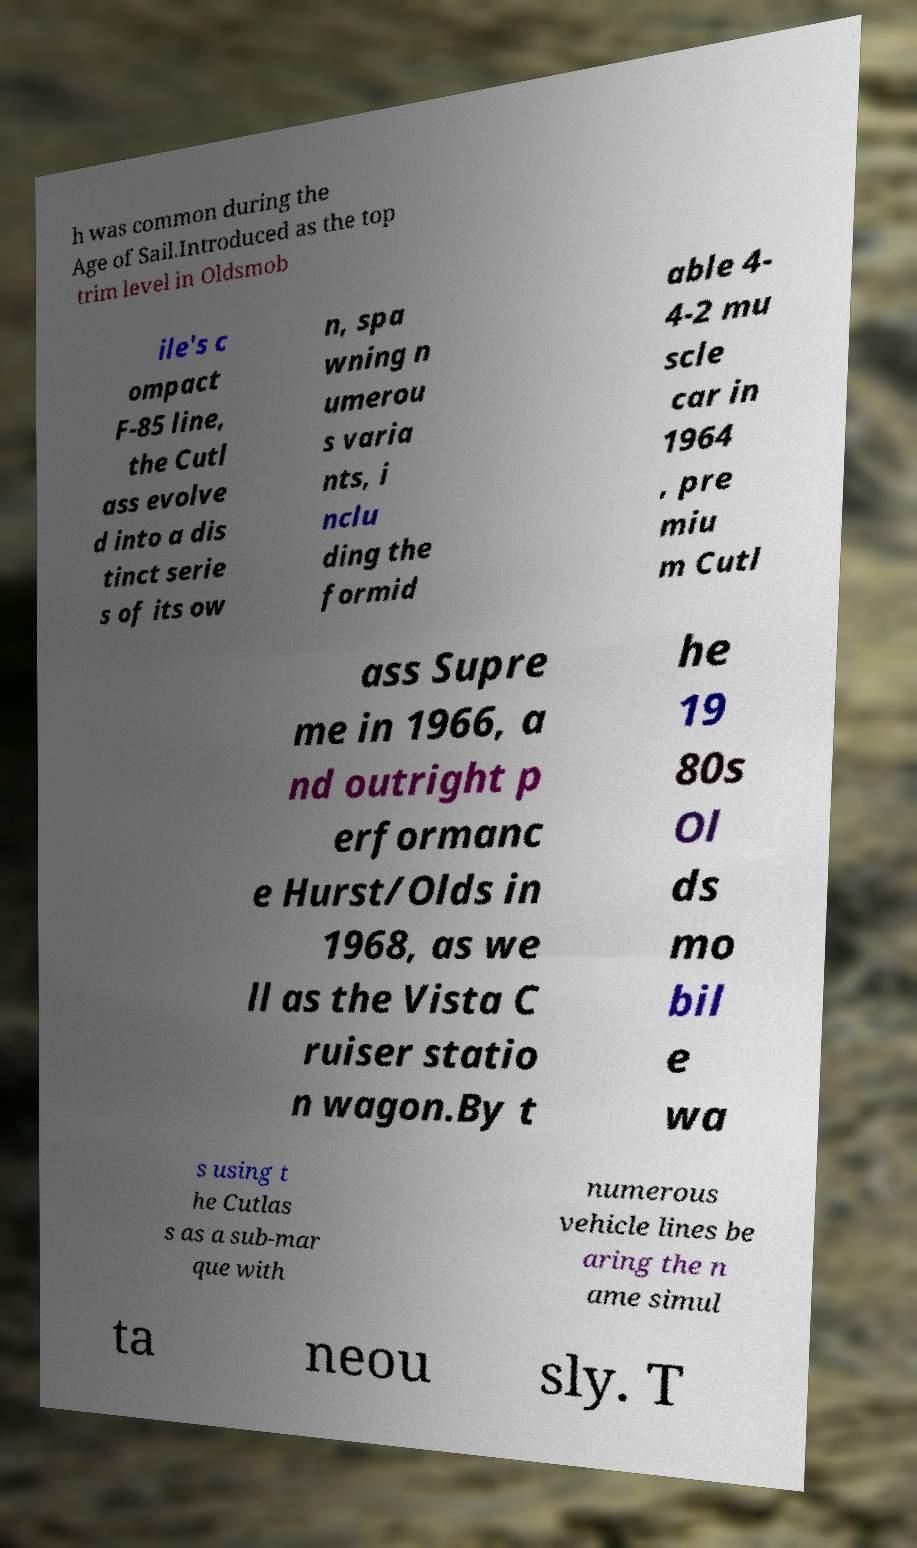I need the written content from this picture converted into text. Can you do that? h was common during the Age of Sail.Introduced as the top trim level in Oldsmob ile's c ompact F-85 line, the Cutl ass evolve d into a dis tinct serie s of its ow n, spa wning n umerou s varia nts, i nclu ding the formid able 4- 4-2 mu scle car in 1964 , pre miu m Cutl ass Supre me in 1966, a nd outright p erformanc e Hurst/Olds in 1968, as we ll as the Vista C ruiser statio n wagon.By t he 19 80s Ol ds mo bil e wa s using t he Cutlas s as a sub-mar que with numerous vehicle lines be aring the n ame simul ta neou sly. T 